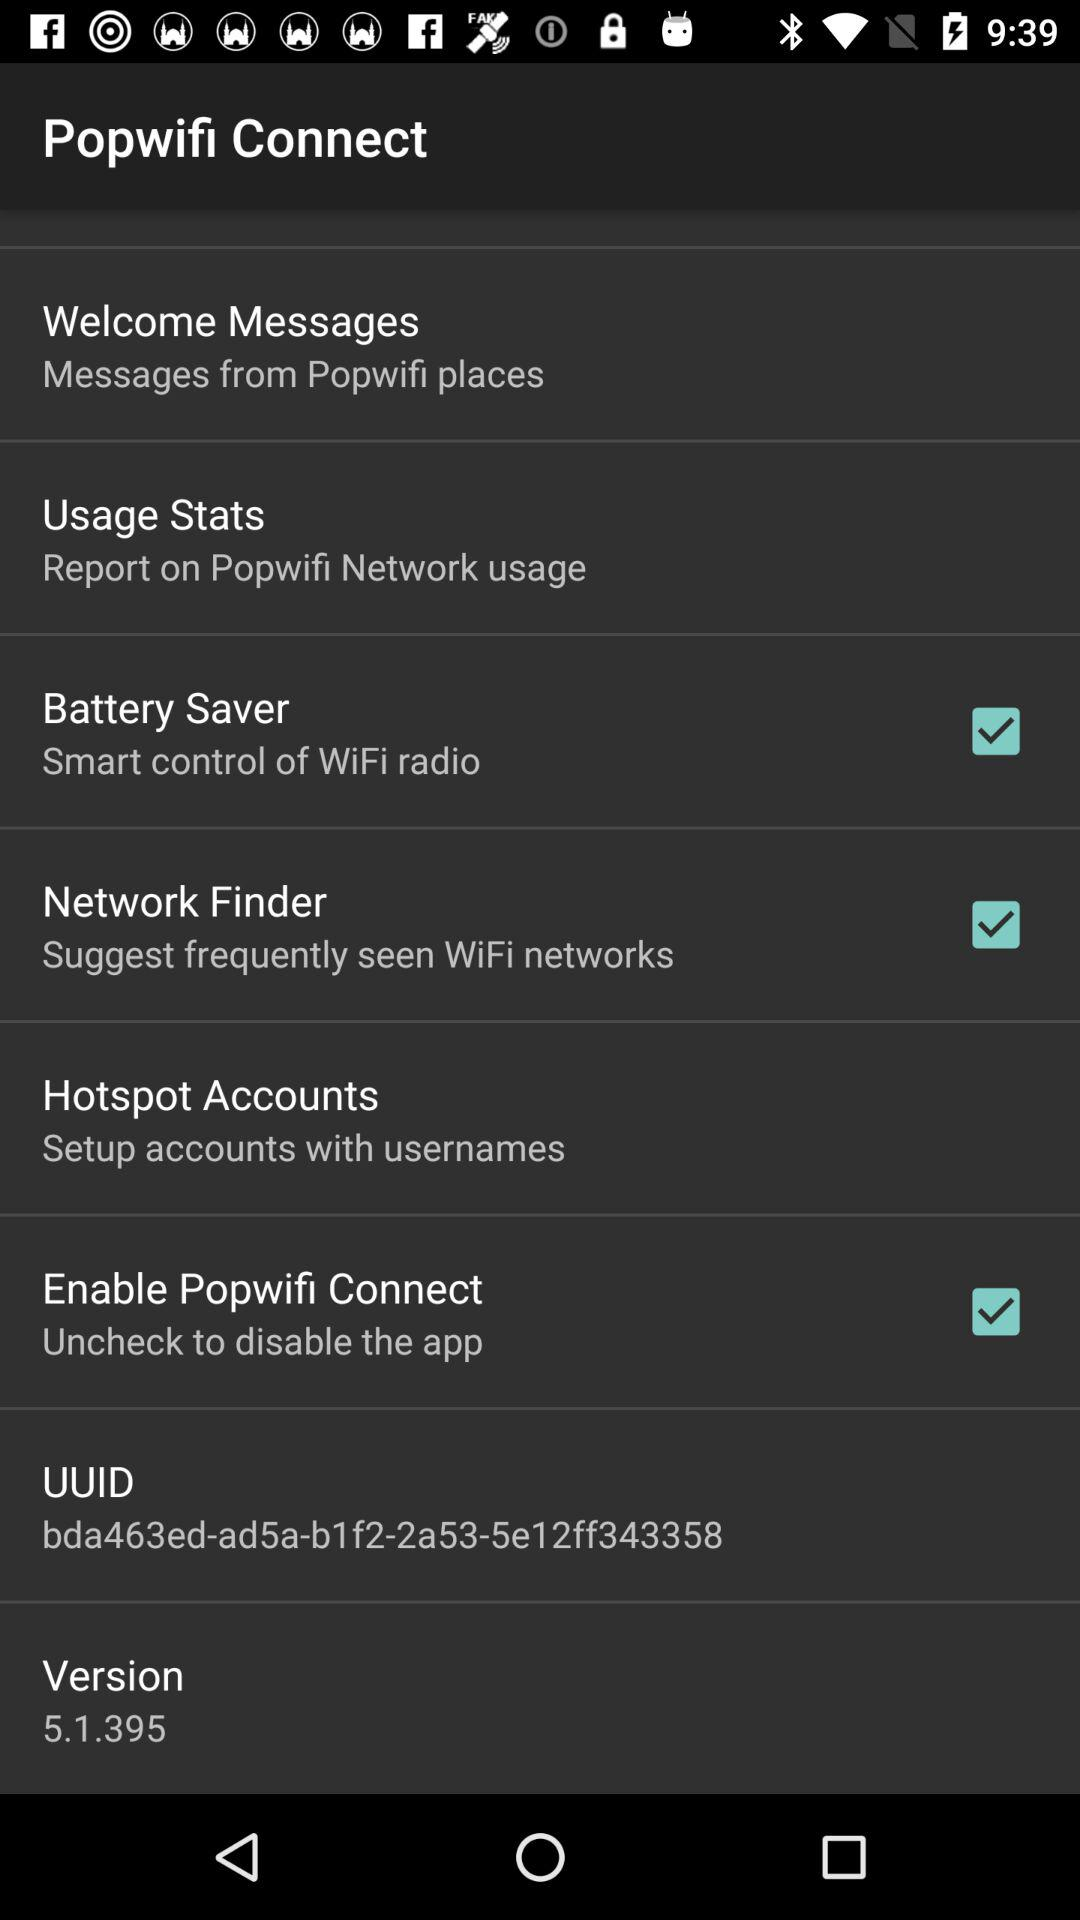What is the UUID? The UUID is "bda463ed-ad5a-b1f2-2a53-5e12ff343358". 